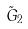Convert formula to latex. <formula><loc_0><loc_0><loc_500><loc_500>\tilde { G } _ { 2 }</formula> 